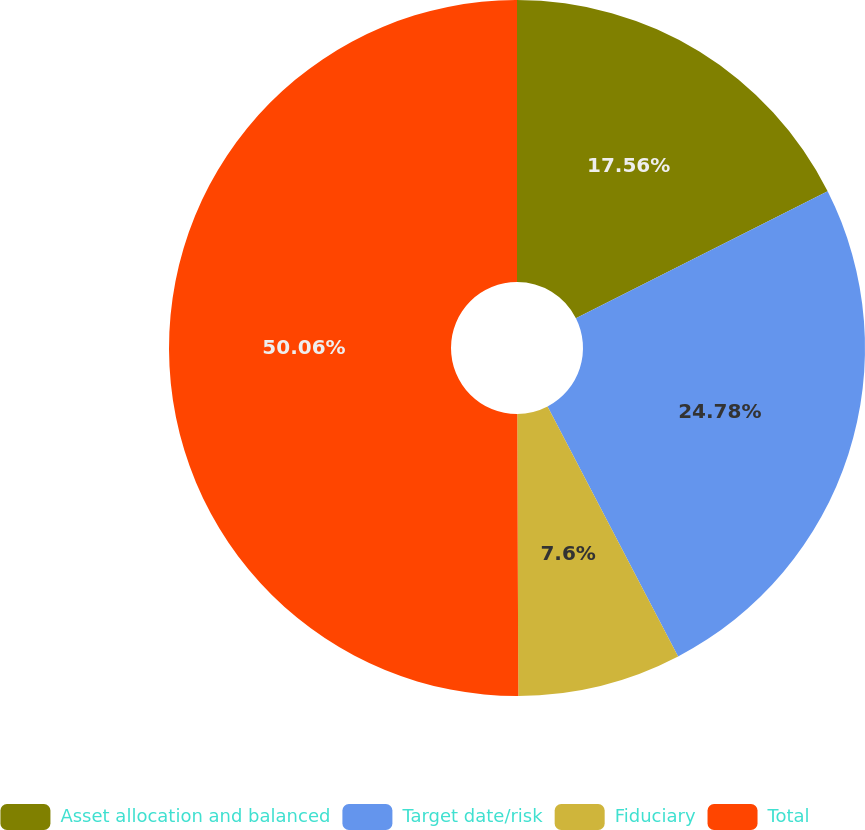Convert chart to OTSL. <chart><loc_0><loc_0><loc_500><loc_500><pie_chart><fcel>Asset allocation and balanced<fcel>Target date/risk<fcel>Fiduciary<fcel>Total<nl><fcel>17.56%<fcel>24.78%<fcel>7.6%<fcel>50.06%<nl></chart> 